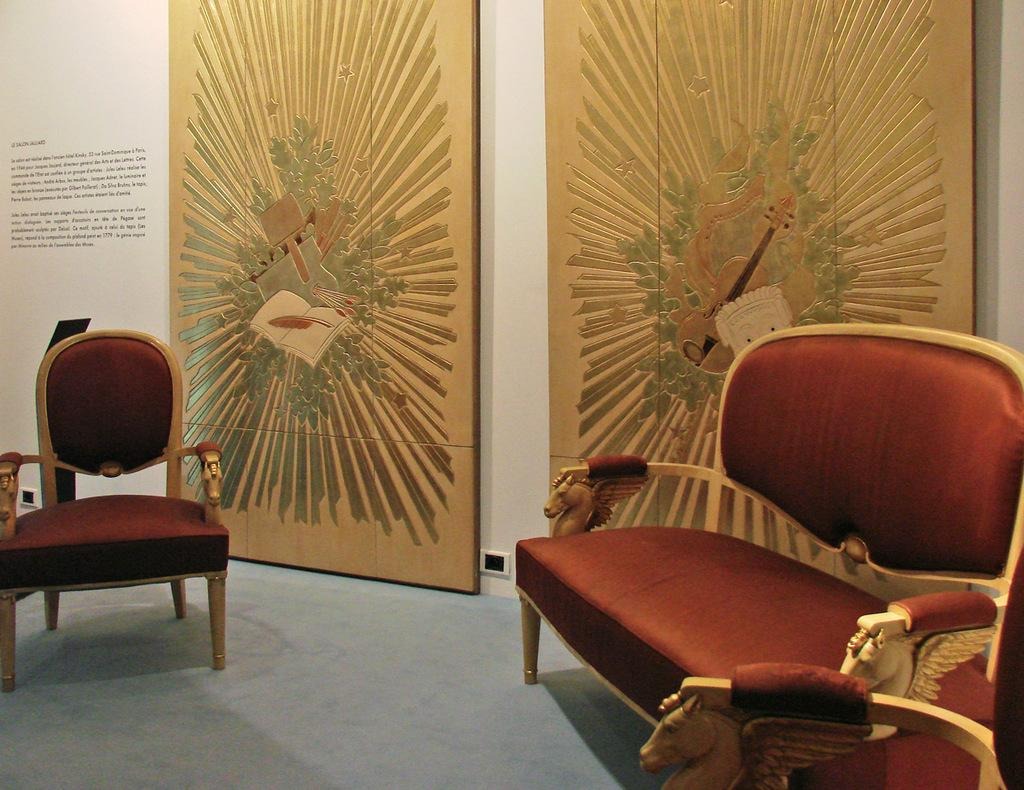What type of furniture is located on the right side of the image? There is a sofa on the right side of the image. What type of furniture is located on the left side of the image? There is a chair on the left side of the image. What can be seen in the background of the image? There are two boards with art printed on them in the background of the image. What is the weight of the pig in the image? There is no pig present in the image, so its weight cannot be determined. What type of toy can be seen on the chair in the image? There is no toy visible on the chair in the image. 